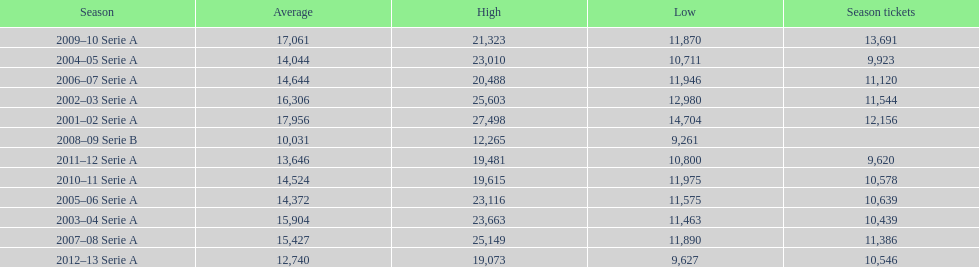What was the average attendance in 2008? 10,031. 